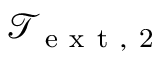<formula> <loc_0><loc_0><loc_500><loc_500>\mathcal { T } _ { e x t , 2 }</formula> 